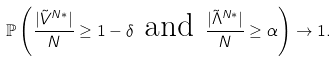Convert formula to latex. <formula><loc_0><loc_0><loc_500><loc_500>\mathbb { P } \left ( \frac { | \tilde { V } ^ { N * } | } { N } \geq 1 - \delta \text { and } \frac { | \tilde { \Lambda } ^ { N * } | } { N } \geq \alpha \right ) \to 1 .</formula> 